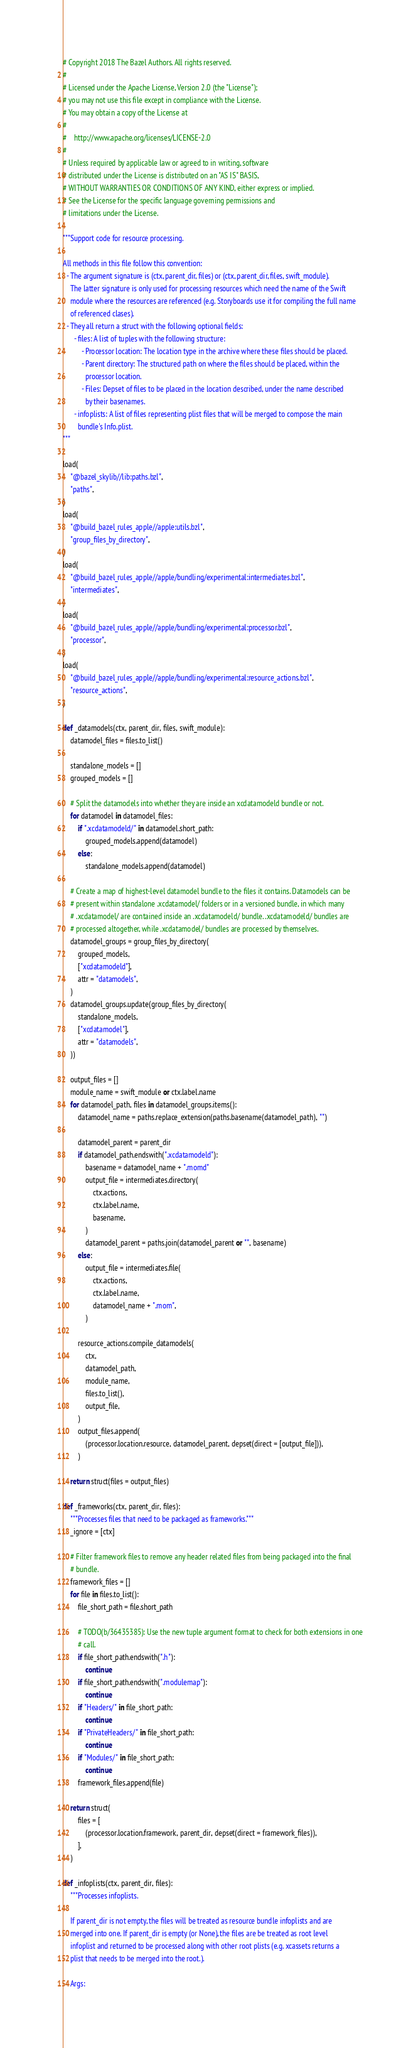Convert code to text. <code><loc_0><loc_0><loc_500><loc_500><_Python_># Copyright 2018 The Bazel Authors. All rights reserved.
#
# Licensed under the Apache License, Version 2.0 (the "License");
# you may not use this file except in compliance with the License.
# You may obtain a copy of the License at
#
#    http://www.apache.org/licenses/LICENSE-2.0
#
# Unless required by applicable law or agreed to in writing, software
# distributed under the License is distributed on an "AS IS" BASIS,
# WITHOUT WARRANTIES OR CONDITIONS OF ANY KIND, either express or implied.
# See the License for the specific language governing permissions and
# limitations under the License.

"""Support code for resource processing.

All methods in this file follow this convention:
  - The argument signature is (ctx, parent_dir, files) or (ctx, parent_dir, files, swift_module).
    The latter signature is only used for processing resources which need the name of the Swift
    module where the resources are referenced (e.g. Storyboards use it for compiling the full name
    of referenced clases).
  - They all return a struct with the following optional fields:
      - files: A list of tuples with the following structure:
          - Processor location: The location type in the archive where these files should be placed.
          - Parent directory: The structured path on where the files should be placed, within the
            processor location.
          - Files: Depset of files to be placed in the location described, under the name described
            by their basenames.
      - infoplists: A list of files representing plist files that will be merged to compose the main
        bundle's Info.plist.
"""

load(
    "@bazel_skylib//lib:paths.bzl",
    "paths",
)
load(
    "@build_bazel_rules_apple//apple:utils.bzl",
    "group_files_by_directory",
)
load(
    "@build_bazel_rules_apple//apple/bundling/experimental:intermediates.bzl",
    "intermediates",
)
load(
    "@build_bazel_rules_apple//apple/bundling/experimental:processor.bzl",
    "processor",
)
load(
    "@build_bazel_rules_apple//apple/bundling/experimental:resource_actions.bzl",
    "resource_actions",
)

def _datamodels(ctx, parent_dir, files, swift_module):
    datamodel_files = files.to_list()

    standalone_models = []
    grouped_models = []

    # Split the datamodels into whether they are inside an xcdatamodeld bundle or not.
    for datamodel in datamodel_files:
        if ".xcdatamodeld/" in datamodel.short_path:
            grouped_models.append(datamodel)
        else:
            standalone_models.append(datamodel)

    # Create a map of highest-level datamodel bundle to the files it contains. Datamodels can be
    # present within standalone .xcdatamodel/ folders or in a versioned bundle, in which many
    # .xcdatamodel/ are contained inside an .xcdatamodeld/ bundle. .xcdatamodeld/ bundles are
    # processed altogether, while .xcdatamodel/ bundles are processed by themselves.
    datamodel_groups = group_files_by_directory(
        grouped_models,
        ["xcdatamodeld"],
        attr = "datamodels",
    )
    datamodel_groups.update(group_files_by_directory(
        standalone_models,
        ["xcdatamodel"],
        attr = "datamodels",
    ))

    output_files = []
    module_name = swift_module or ctx.label.name
    for datamodel_path, files in datamodel_groups.items():
        datamodel_name = paths.replace_extension(paths.basename(datamodel_path), "")

        datamodel_parent = parent_dir
        if datamodel_path.endswith(".xcdatamodeld"):
            basename = datamodel_name + ".momd"
            output_file = intermediates.directory(
                ctx.actions,
                ctx.label.name,
                basename,
            )
            datamodel_parent = paths.join(datamodel_parent or "", basename)
        else:
            output_file = intermediates.file(
                ctx.actions,
                ctx.label.name,
                datamodel_name + ".mom",
            )

        resource_actions.compile_datamodels(
            ctx,
            datamodel_path,
            module_name,
            files.to_list(),
            output_file,
        )
        output_files.append(
            (processor.location.resource, datamodel_parent, depset(direct = [output_file])),
        )

    return struct(files = output_files)

def _frameworks(ctx, parent_dir, files):
    """Processes files that need to be packaged as frameworks."""
    _ignore = [ctx]

    # Filter framework files to remove any header related files from being packaged into the final
    # bundle.
    framework_files = []
    for file in files.to_list():
        file_short_path = file.short_path

        # TODO(b/36435385): Use the new tuple argument format to check for both extensions in one
        # call.
        if file_short_path.endswith(".h"):
            continue
        if file_short_path.endswith(".modulemap"):
            continue
        if "Headers/" in file_short_path:
            continue
        if "PrivateHeaders/" in file_short_path:
            continue
        if "Modules/" in file_short_path:
            continue
        framework_files.append(file)

    return struct(
        files = [
            (processor.location.framework, parent_dir, depset(direct = framework_files)),
        ],
    )

def _infoplists(ctx, parent_dir, files):
    """Processes infoplists.

    If parent_dir is not empty, the files will be treated as resource bundle infoplists and are
    merged into one. If parent_dir is empty (or None), the files are be treated as root level
    infoplist and returned to be processed along with other root plists (e.g. xcassets returns a
    plist that needs to be merged into the root.).

    Args:</code> 